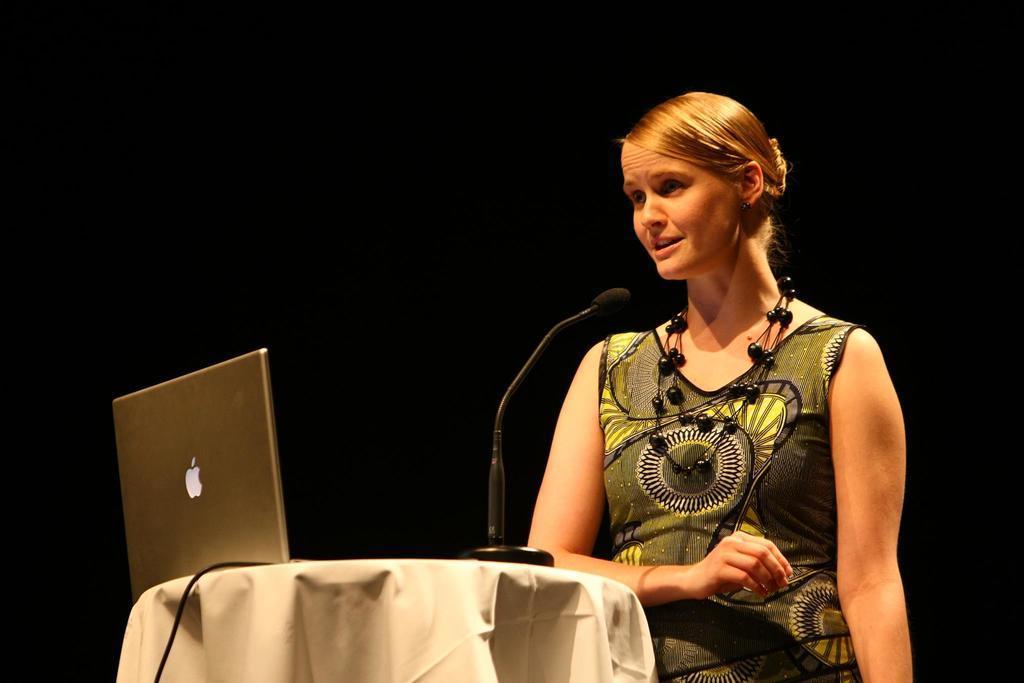Can you describe this image briefly? In the picture we can see a woman wearing multi color dress standing in front of her there is table on which there is laptop, microphone and in the background there is dark view. 